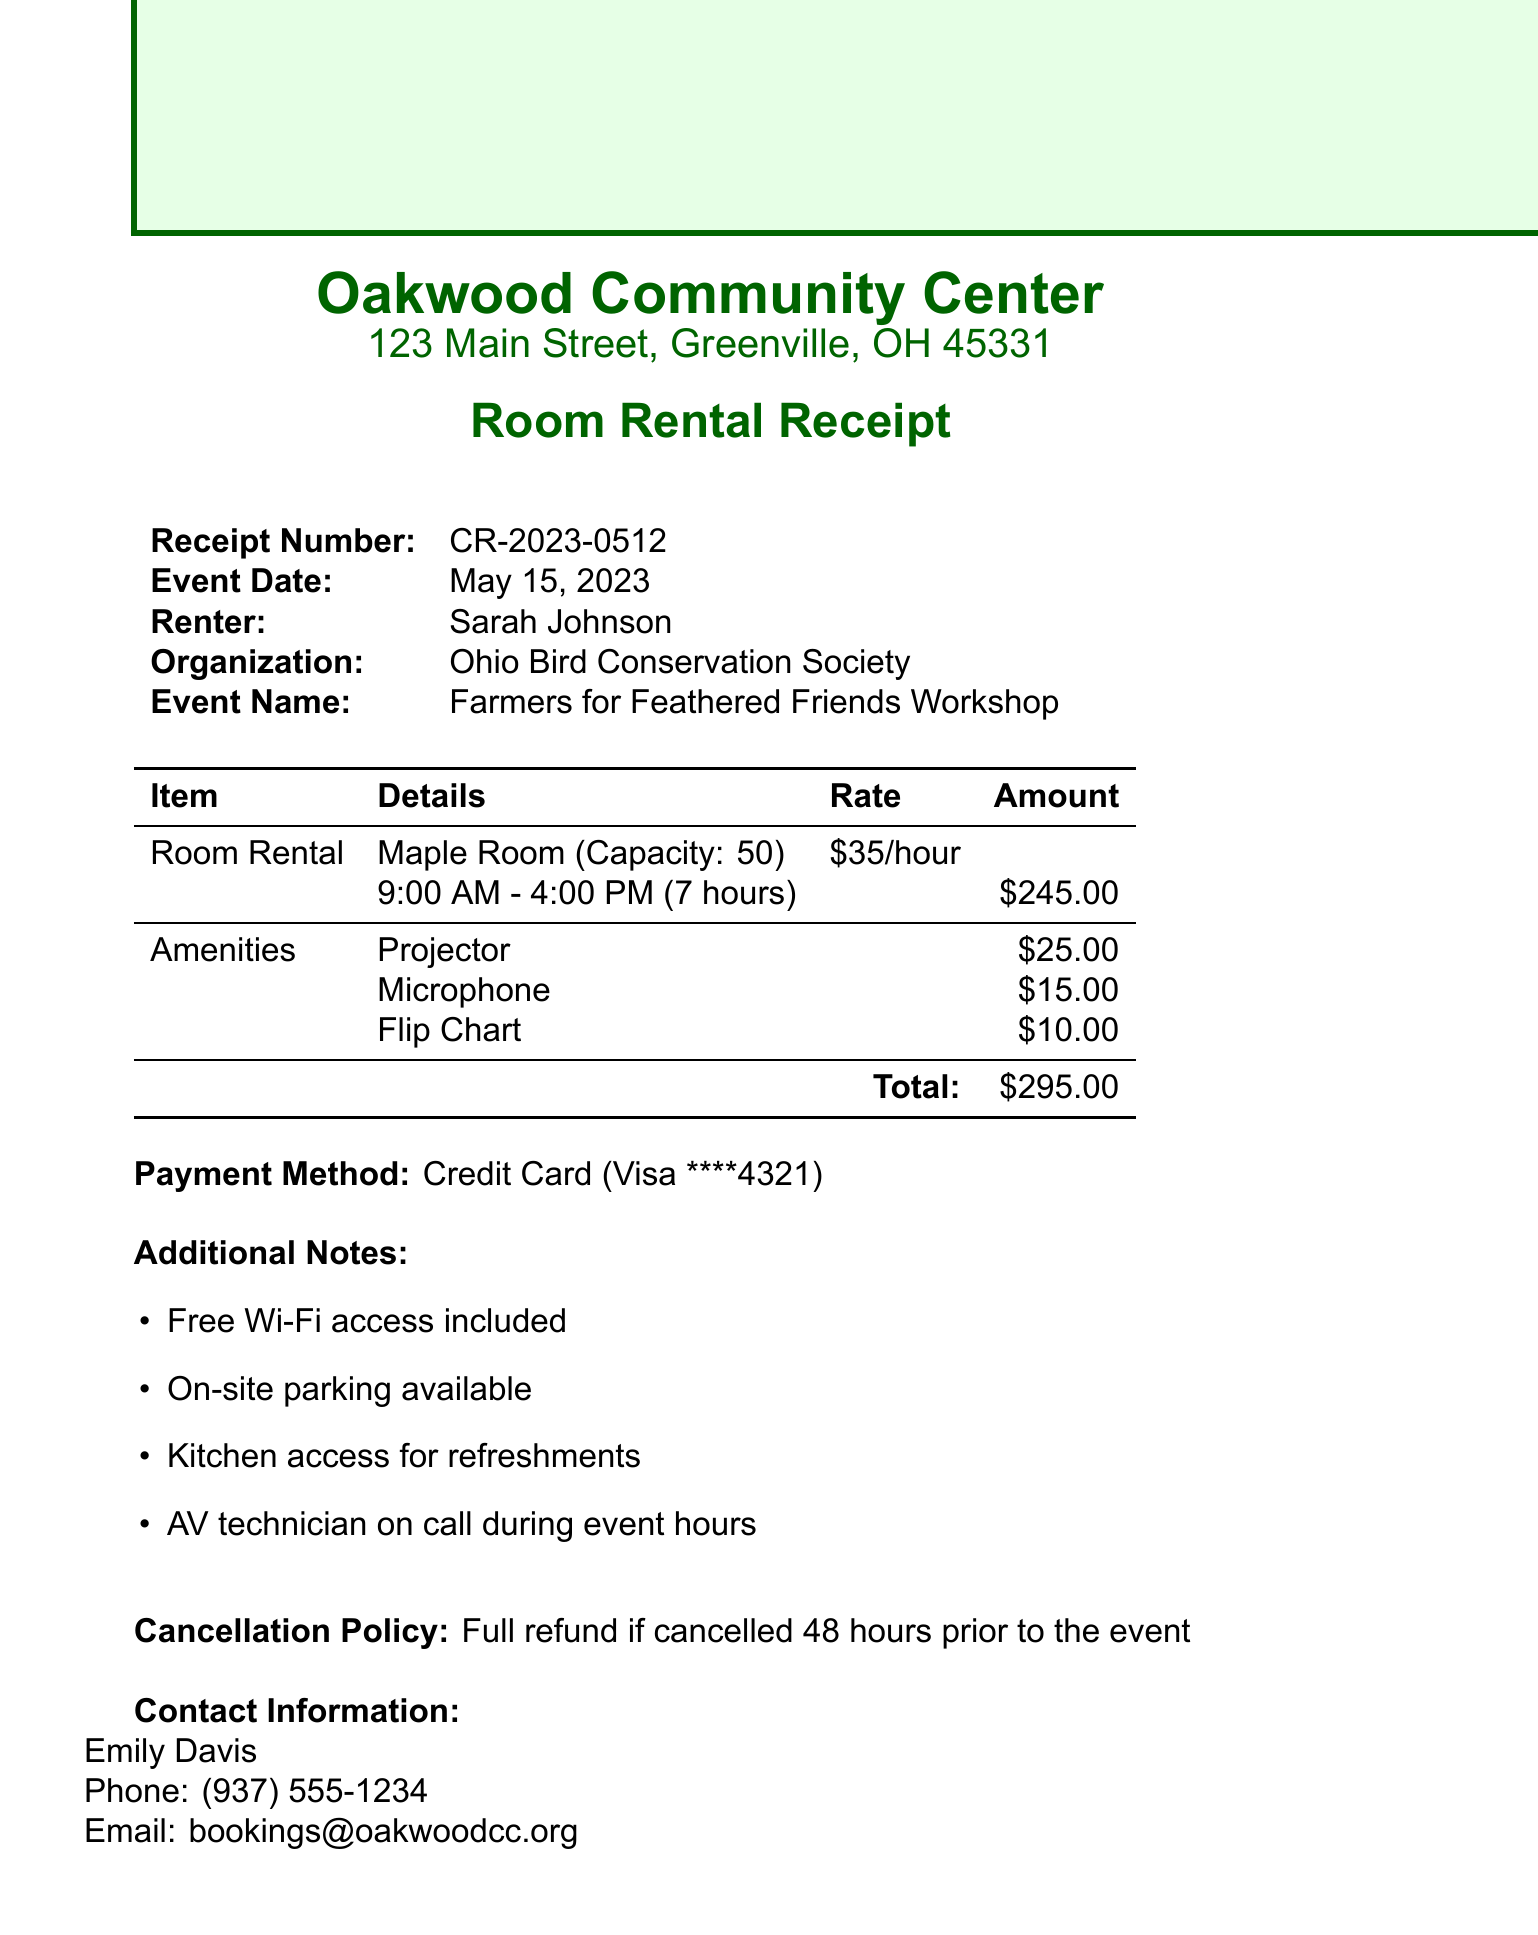what is the receipt number? The receipt number is listed at the top of the document for reference.
Answer: CR-2023-0512 who is the renter? The renter's name is provided in the document to identify who booked the room.
Answer: Sarah Johnson what is the total cost? The total cost is the final amount that includes room rental and amenities as shown in the document.
Answer: $295.00 how many hours is the event scheduled for? The event duration is specified, indicating how long the room will be used.
Answer: 7 hours what amenities were included? The document lists specific amenities that were provided for the event at additional costs.
Answer: Projector, Microphone, Flip Chart what is the cancellation policy? The cancellation policy outlines the conditions under which a refund can be obtained.
Answer: Full refund if cancelled 48 hours prior to the event what is included with the room rental? The document lists any additional features or services included with the room rental.
Answer: Free Wi-Fi access, On-site parking, Kitchen access, AV technician what is the capacity of the Maple Room? The room capacity is stated clearly in the document, which indicates how many people can fit.
Answer: 50 who should be contacted for more information? The document specifies a contact person for any inquiries related to the booking.
Answer: Emily Davis 